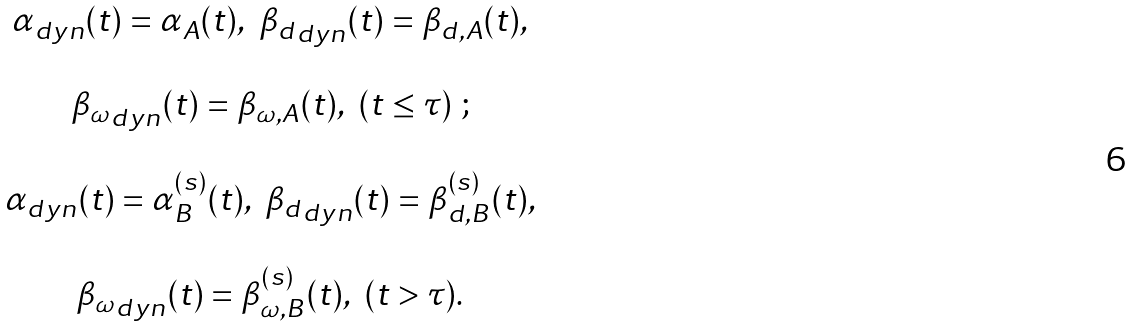Convert formula to latex. <formula><loc_0><loc_0><loc_500><loc_500>\begin{array} { c } \alpha _ { d y n } ( t ) = \alpha _ { A } ( t ) , \ { \beta _ { d } } _ { d y n } ( t ) = \beta _ { d , A } ( t ) , \\ \\ { \beta _ { \omega } } _ { d y n } ( t ) = \beta _ { \omega , A } ( t ) , \ ( t \leq \tau ) \ ; \\ \\ \alpha _ { d y n } ( t ) = \alpha _ { B } ^ { ( s ) } ( t ) , \ { \beta _ { d } } _ { d y n } ( t ) = \beta _ { d , B } ^ { ( s ) } ( t ) , \\ \\ { \beta _ { \omega } } _ { d y n } ( t ) = \beta _ { \omega , B } ^ { ( s ) } ( t ) , \ ( t > \tau ) . \end{array}</formula> 